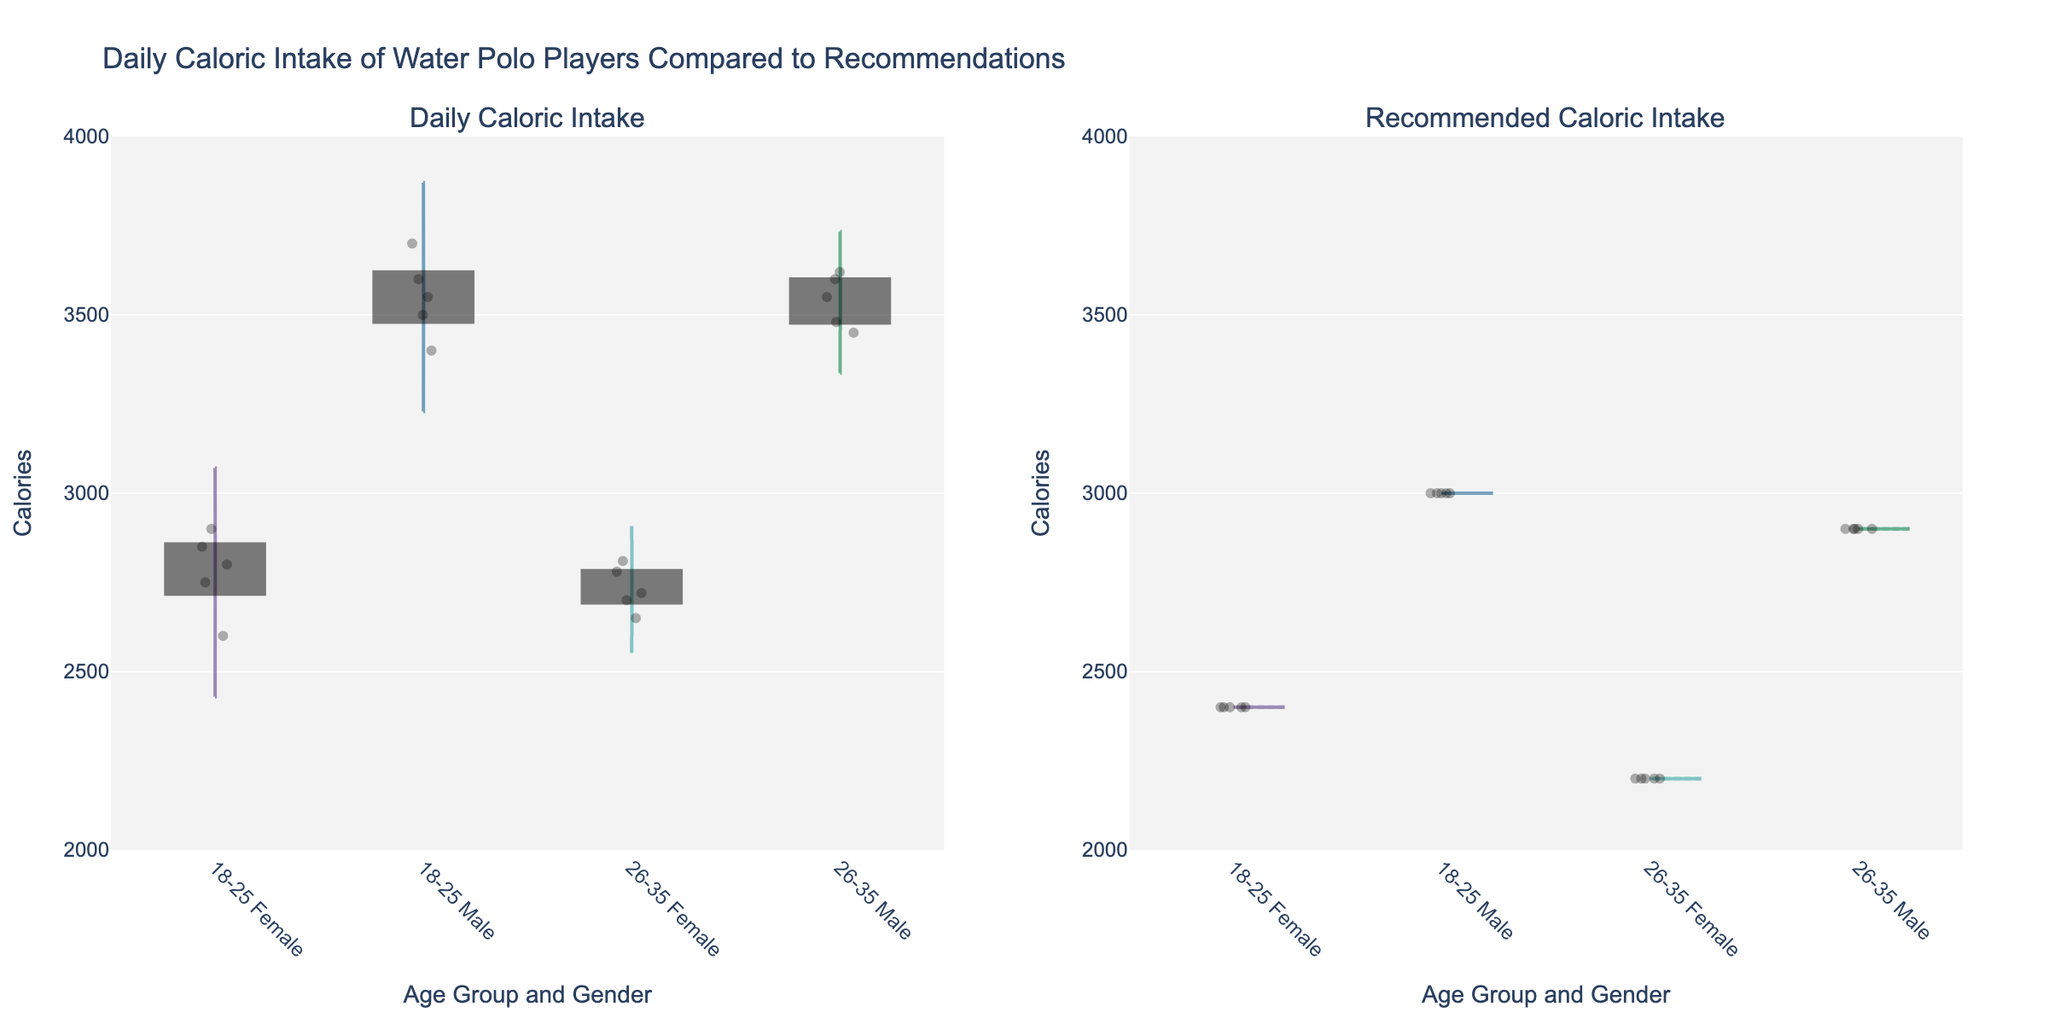What's the title of the figure? The title is written at the top of the figure.
Answer: Daily Caloric Intake of Water Polo Players Compared to Recommendations How many age groups are represented in the data? Each unique age group appears as a label on the x-axis. By counting these labels, you can determine the number of age groups.
Answer: 2 Which gender, within the 18-25 age group, has a higher average daily caloric intake? To compare the averages, observe the central tendencies of the violin plots for males and females in the 18-25 age group. The male plot is positioned higher on the y-axis than the female plot.
Answer: Male Are the recommended caloric intakes generally higher or lower than the actual daily caloric intakes for the same age and gender groups? Compare the height positions of the violin plots between the daily and recommended caloric intake subplots. The actual intake plot generally appears higher.
Answer: Higher Looking at the 26-35 age group, which gender has the most tightly clustered data points for daily caloric intake? The clustering can be observed by examining the dispersion of jittered points within the violin plot. Less dispersion indicates more tightly clustered data.
Answer: Female What's the average recommended caloric intake for the 26-35 year-old males? Check the central tendency (e.g., the mean line) of the recommended caloric intake violin plot for 26-35 year-old males. The value should align with the average recommendation observed in the Blue plot.
Answer: 2900 Which group shows the widest range in daily caloric intake? Identify the difference between the highest and lowest points within the violin plot. The group with the largest spread indicates the widest range.
Answer: Male 18-25 For the 18-25 age group, what's the difference between the average daily caloric intake of males and females? Determine the mean values for both males and females from the violin plots and subtract the female mean from the male mean.
Answer: ~750 calories Are there any gender-age groups where the average daily caloric intake exceeds the recommended caloric intake by more than 500 calories? Compare the mean lines of daily and recommended caloric intake for each gender-age group. Identify any group where the mean line of daily intake is more than 500 calories above the recommended intake mean line.
Answer: Yes, Male 18-25 and Male 26-35 